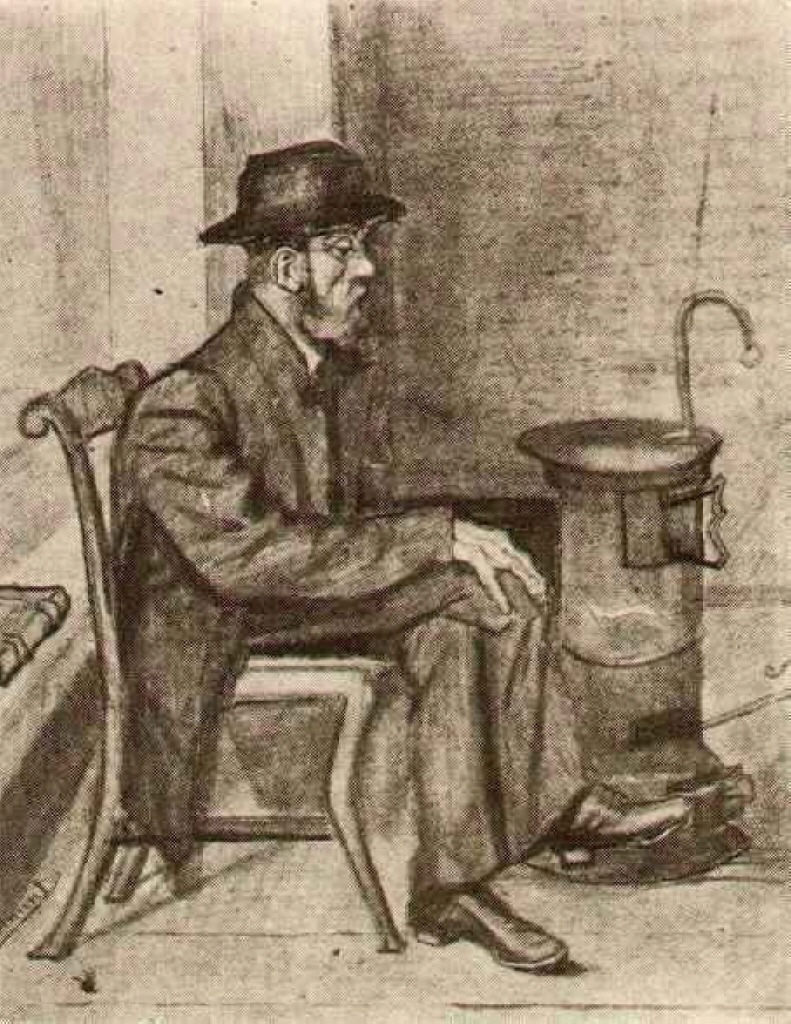Invent a fantastical backstory involving the stove having magical properties. In a distant past, the stove was forged from an enchanted metal that grants warmth to both body and soul. It is said that the fire within it was lit by a mystical flame, gifted by a benevolent spirit of winter. Whoever sits by this stove finds not only physical warmth but also glimpses of their deepest desires and truths. The man in the image, unbeknownst to many, is the ward of this magical artifact. Each evening, as he sits in quiet reflection, the stove reveals secrets of the past and visions of potential futures, guiding him through life's complexities. The man’s introspective gaze hints at the knowledge and wisdom imparted by the enchanted flames, making him both a keeper and a seeker of hidden truths and mystical tales. 